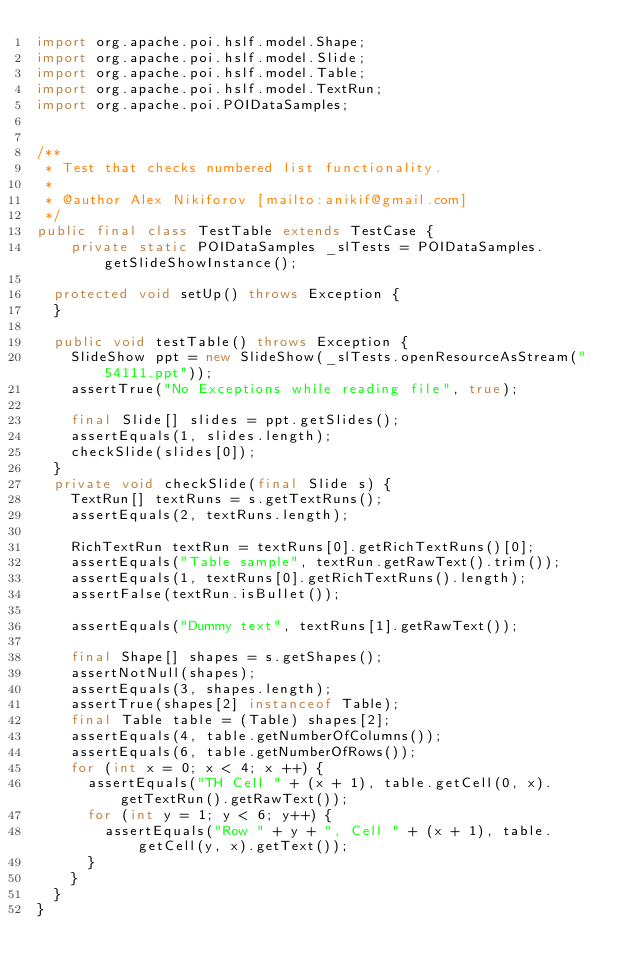<code> <loc_0><loc_0><loc_500><loc_500><_Java_>import org.apache.poi.hslf.model.Shape;
import org.apache.poi.hslf.model.Slide;
import org.apache.poi.hslf.model.Table;
import org.apache.poi.hslf.model.TextRun;
import org.apache.poi.POIDataSamples;


/**
 * Test that checks numbered list functionality.
 * 
 * @author Alex Nikiforov [mailto:anikif@gmail.com]
 */
public final class TestTable extends TestCase {
    private static POIDataSamples _slTests = POIDataSamples.getSlideShowInstance();

	protected void setUp() throws Exception {
	}

	public void testTable() throws Exception {
		SlideShow ppt = new SlideShow(_slTests.openResourceAsStream("54111.ppt"));
		assertTrue("No Exceptions while reading file", true);

		final Slide[] slides = ppt.getSlides();
		assertEquals(1, slides.length);
		checkSlide(slides[0]);
	}
	private void checkSlide(final Slide s) {
		TextRun[] textRuns = s.getTextRuns();
		assertEquals(2, textRuns.length);

		RichTextRun textRun = textRuns[0].getRichTextRuns()[0];
		assertEquals("Table sample", textRun.getRawText().trim());
		assertEquals(1, textRuns[0].getRichTextRuns().length);
		assertFalse(textRun.isBullet());

		assertEquals("Dummy text", textRuns[1].getRawText());
		
		final Shape[] shapes = s.getShapes();
		assertNotNull(shapes);
		assertEquals(3, shapes.length);
		assertTrue(shapes[2] instanceof Table);
		final Table table = (Table) shapes[2];
		assertEquals(4, table.getNumberOfColumns());
		assertEquals(6, table.getNumberOfRows());
		for (int x = 0; x < 4; x ++) {
			assertEquals("TH Cell " + (x + 1), table.getCell(0, x).getTextRun().getRawText());
			for (int y = 1; y < 6; y++) {
				assertEquals("Row " + y + ", Cell " + (x + 1), table.getCell(y, x).getText());
			}
		}
	}
}
</code> 